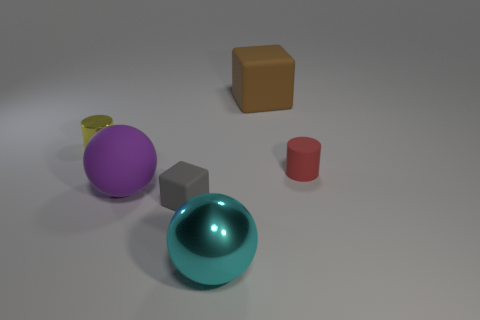There is a large thing that is on the right side of the metallic thing that is right of the tiny gray matte thing; is there a large rubber object in front of it?
Keep it short and to the point. Yes. How many big rubber spheres are the same color as the metal ball?
Make the answer very short. 0. What is the size of the block that is right of the large ball that is in front of the rubber ball?
Make the answer very short. Large. How many objects are cubes left of the large rubber block or large purple metallic objects?
Make the answer very short. 1. Are there any purple matte spheres that have the same size as the brown matte thing?
Make the answer very short. Yes. There is a large object that is on the left side of the cyan shiny sphere; is there a red cylinder on the right side of it?
Provide a short and direct response. Yes. What number of cylinders are brown objects or red things?
Your answer should be compact. 1. Is there another small gray thing of the same shape as the small gray thing?
Give a very brief answer. No. What is the shape of the purple matte thing?
Give a very brief answer. Sphere. How many objects are either cubes or brown matte objects?
Give a very brief answer. 2. 